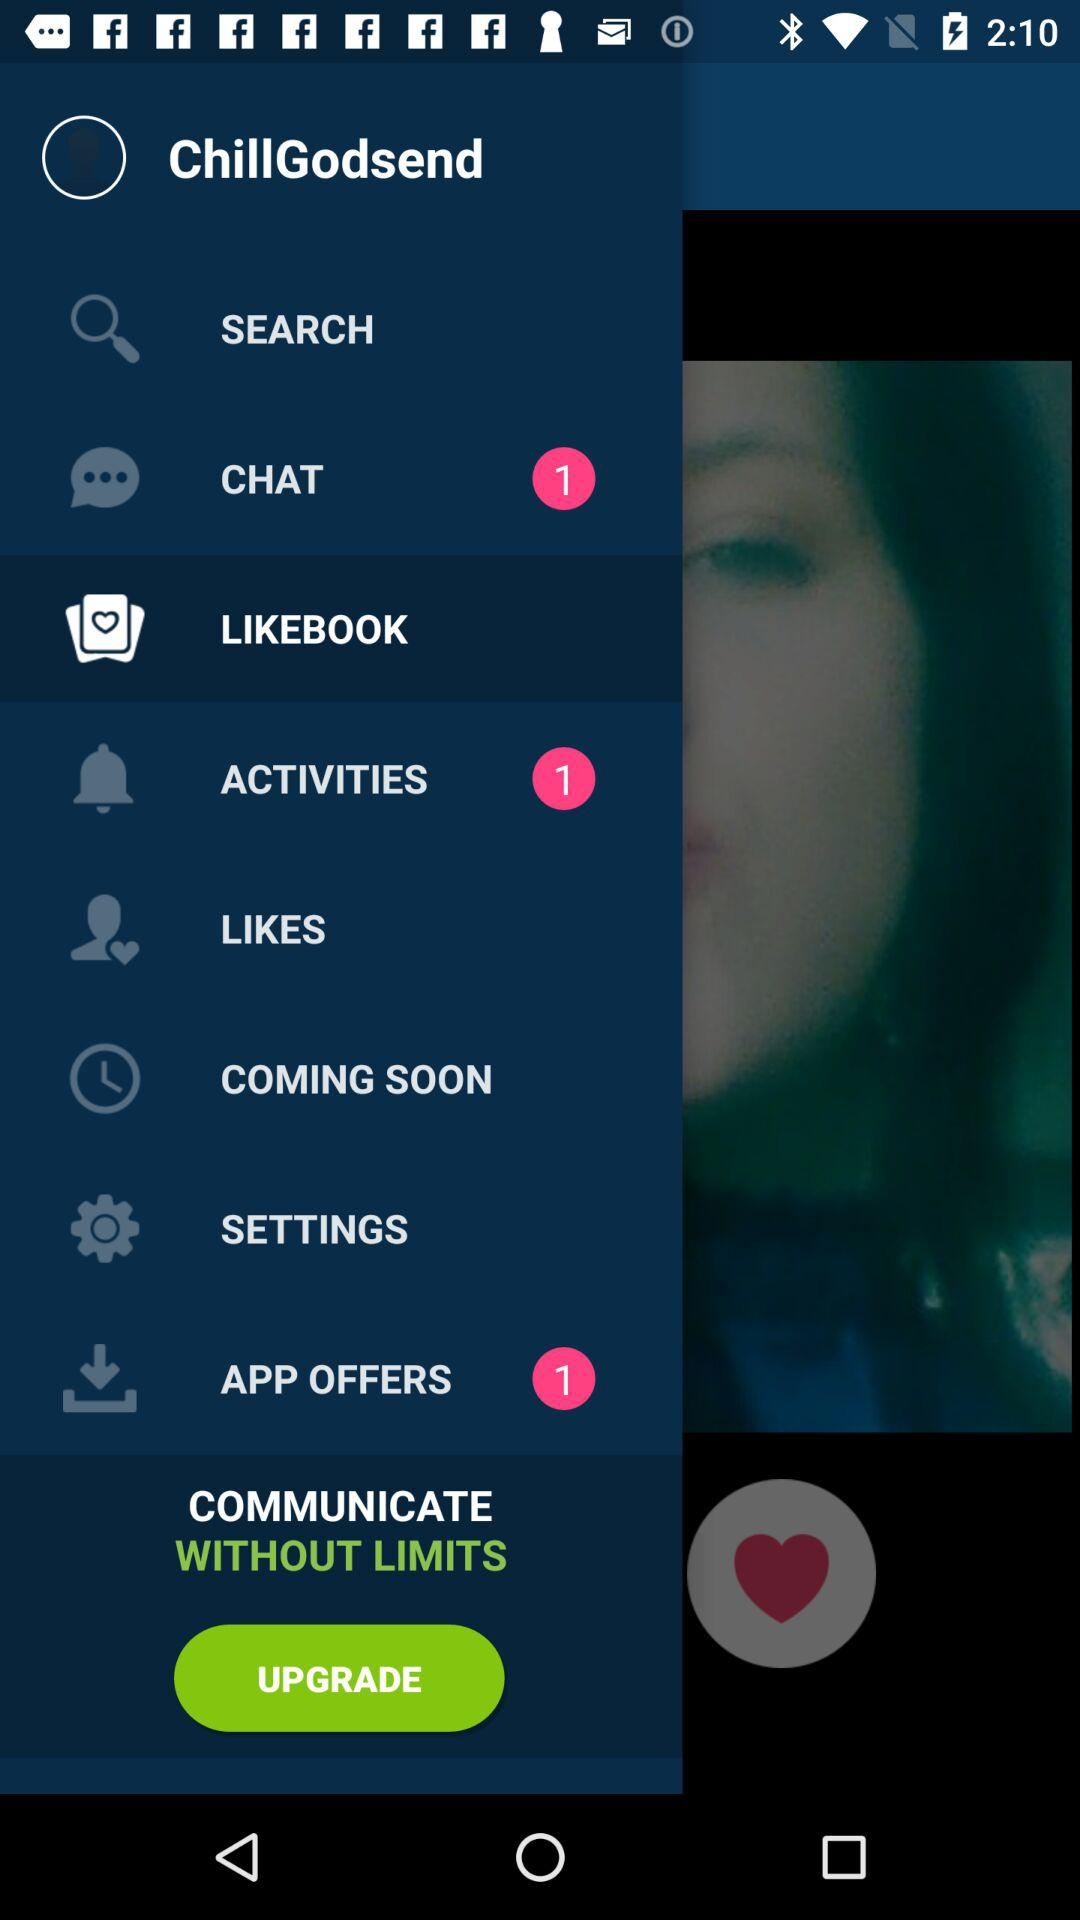How many chats are unread? There is 1 unread chat. 